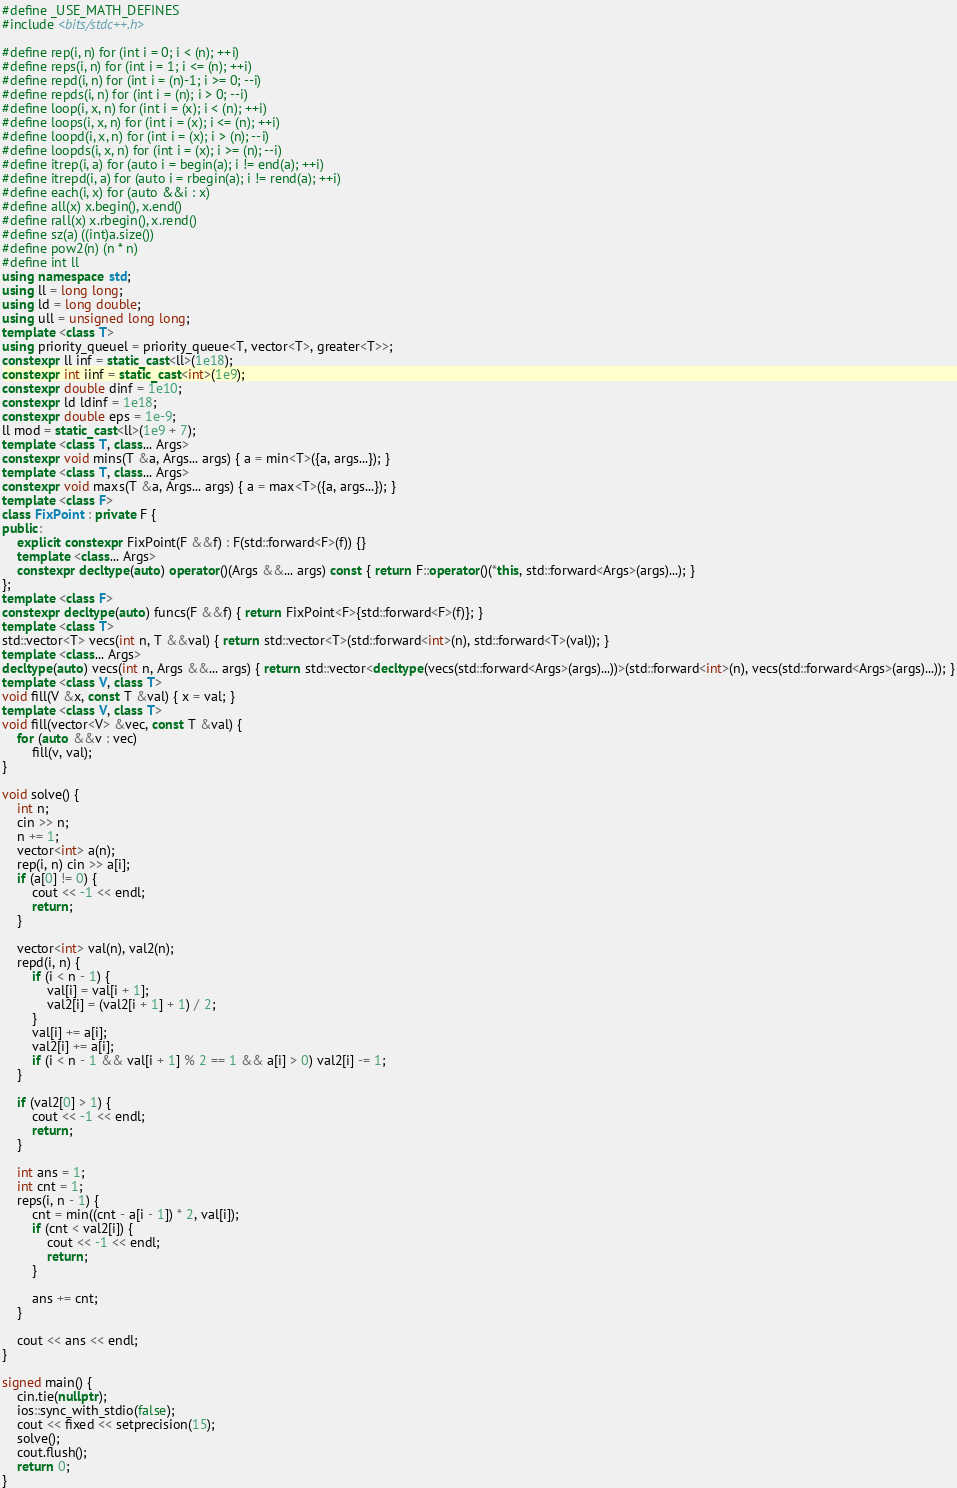Convert code to text. <code><loc_0><loc_0><loc_500><loc_500><_C++_>#define _USE_MATH_DEFINES
#include <bits/stdc++.h>

#define rep(i, n) for (int i = 0; i < (n); ++i)
#define reps(i, n) for (int i = 1; i <= (n); ++i)
#define repd(i, n) for (int i = (n)-1; i >= 0; --i)
#define repds(i, n) for (int i = (n); i > 0; --i)
#define loop(i, x, n) for (int i = (x); i < (n); ++i)
#define loops(i, x, n) for (int i = (x); i <= (n); ++i)
#define loopd(i, x, n) for (int i = (x); i > (n); --i)
#define loopds(i, x, n) for (int i = (x); i >= (n); --i)
#define itrep(i, a) for (auto i = begin(a); i != end(a); ++i)
#define itrepd(i, a) for (auto i = rbegin(a); i != rend(a); ++i)
#define each(i, x) for (auto &&i : x)
#define all(x) x.begin(), x.end()
#define rall(x) x.rbegin(), x.rend()
#define sz(a) ((int)a.size())
#define pow2(n) (n * n)
#define int ll
using namespace std;
using ll = long long;
using ld = long double;
using ull = unsigned long long;
template <class T>
using priority_queuel = priority_queue<T, vector<T>, greater<T>>;
constexpr ll inf = static_cast<ll>(1e18);
constexpr int iinf = static_cast<int>(1e9);
constexpr double dinf = 1e10;
constexpr ld ldinf = 1e18;
constexpr double eps = 1e-9;
ll mod = static_cast<ll>(1e9 + 7);
template <class T, class... Args>
constexpr void mins(T &a, Args... args) { a = min<T>({a, args...}); }
template <class T, class... Args>
constexpr void maxs(T &a, Args... args) { a = max<T>({a, args...}); }
template <class F>
class FixPoint : private F {
public:
    explicit constexpr FixPoint(F &&f) : F(std::forward<F>(f)) {}
    template <class... Args>
    constexpr decltype(auto) operator()(Args &&... args) const { return F::operator()(*this, std::forward<Args>(args)...); }
};
template <class F>
constexpr decltype(auto) funcs(F &&f) { return FixPoint<F>{std::forward<F>(f)}; }
template <class T>
std::vector<T> vecs(int n, T &&val) { return std::vector<T>(std::forward<int>(n), std::forward<T>(val)); }
template <class... Args>
decltype(auto) vecs(int n, Args &&... args) { return std::vector<decltype(vecs(std::forward<Args>(args)...))>(std::forward<int>(n), vecs(std::forward<Args>(args)...)); }
template <class V, class T>
void fill(V &x, const T &val) { x = val; }
template <class V, class T>
void fill(vector<V> &vec, const T &val) {
    for (auto &&v : vec)
        fill(v, val);
}

void solve() {
    int n;
    cin >> n;
    n += 1;
    vector<int> a(n);
    rep(i, n) cin >> a[i];
    if (a[0] != 0) {
        cout << -1 << endl;
        return;
    }

    vector<int> val(n), val2(n);
    repd(i, n) {
        if (i < n - 1) {
            val[i] = val[i + 1];
            val2[i] = (val2[i + 1] + 1) / 2;
        }
        val[i] += a[i];
        val2[i] += a[i];
        if (i < n - 1 && val[i + 1] % 2 == 1 && a[i] > 0) val2[i] -= 1;
    }

    if (val2[0] > 1) {
        cout << -1 << endl;
        return;
    }

    int ans = 1;
    int cnt = 1;
    reps(i, n - 1) {
        cnt = min((cnt - a[i - 1]) * 2, val[i]);
        if (cnt < val2[i]) {
            cout << -1 << endl;
            return;
        }

        ans += cnt;
    }

    cout << ans << endl;
}

signed main() {
    cin.tie(nullptr);
    ios::sync_with_stdio(false);
    cout << fixed << setprecision(15);
    solve();
    cout.flush();
    return 0;
}</code> 